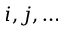<formula> <loc_0><loc_0><loc_500><loc_500>i , j , \dots</formula> 